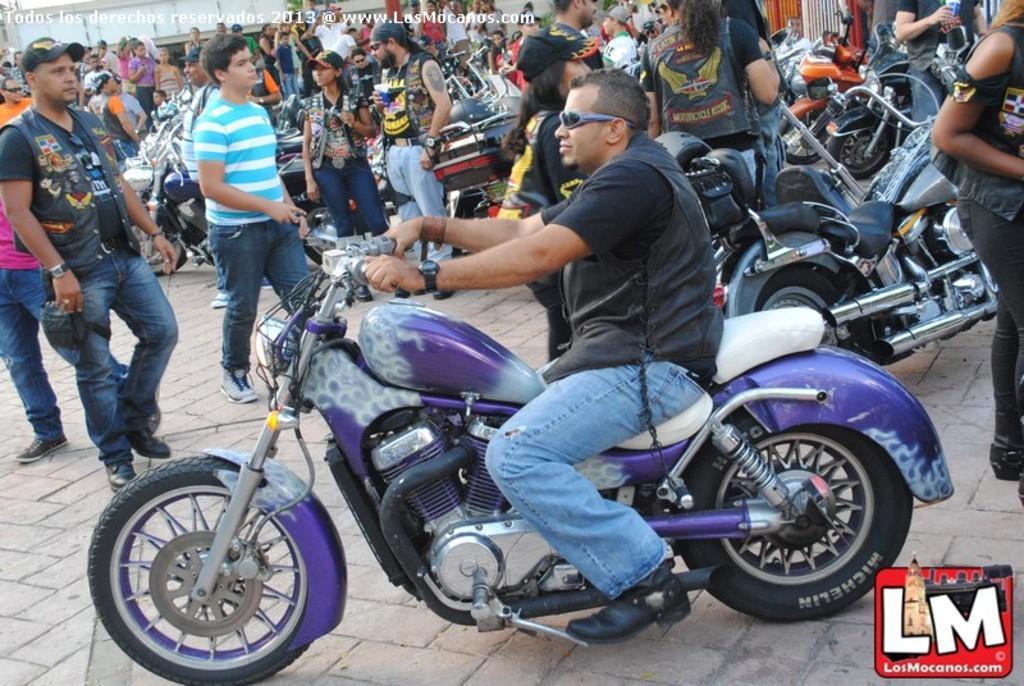Describe this image in one or two sentences. This picture describes about group of people, a man is riding a bicycle, few are walking and few are standing. 